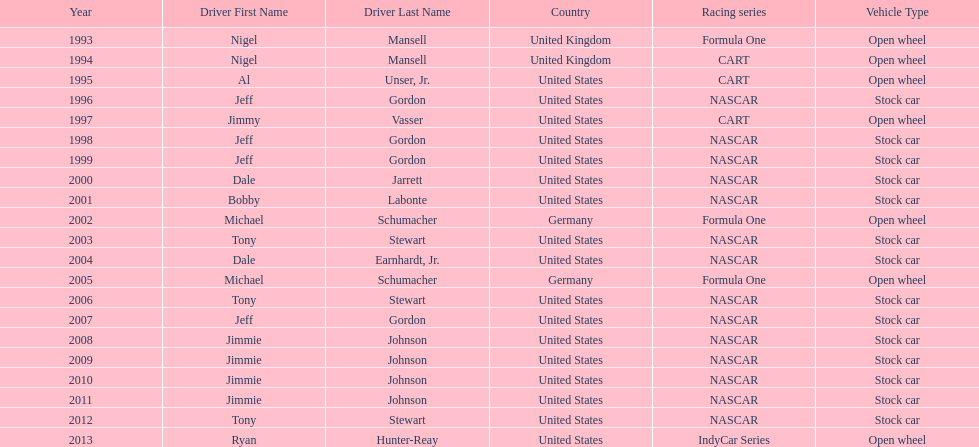Out of these drivers: nigel mansell, al unser, jr., michael schumacher, and jeff gordon, all but one has more than one espy award. who only has one espy award? Al Unser, Jr. 